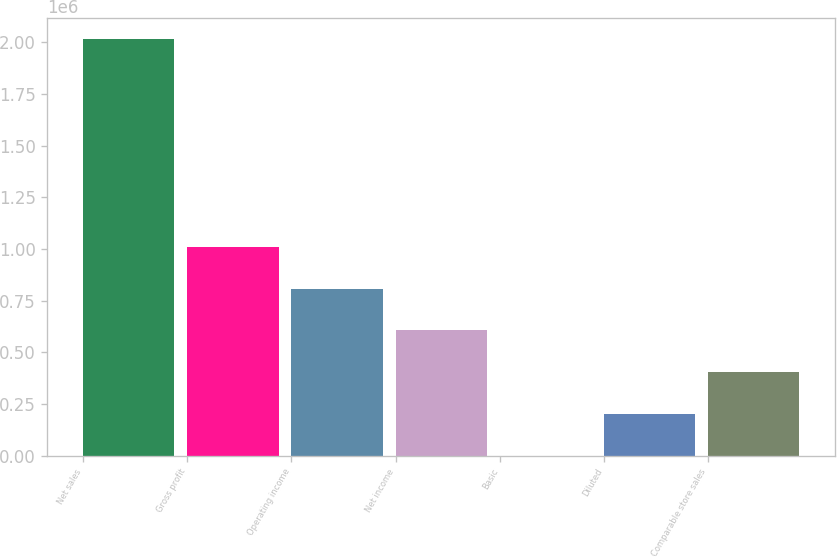Convert chart to OTSL. <chart><loc_0><loc_0><loc_500><loc_500><bar_chart><fcel>Net sales<fcel>Gross profit<fcel>Operating income<fcel>Net income<fcel>Basic<fcel>Diluted<fcel>Comparable store sales<nl><fcel>2.01776e+06<fcel>1.00888e+06<fcel>807106<fcel>605329<fcel>1.25<fcel>201777<fcel>403553<nl></chart> 